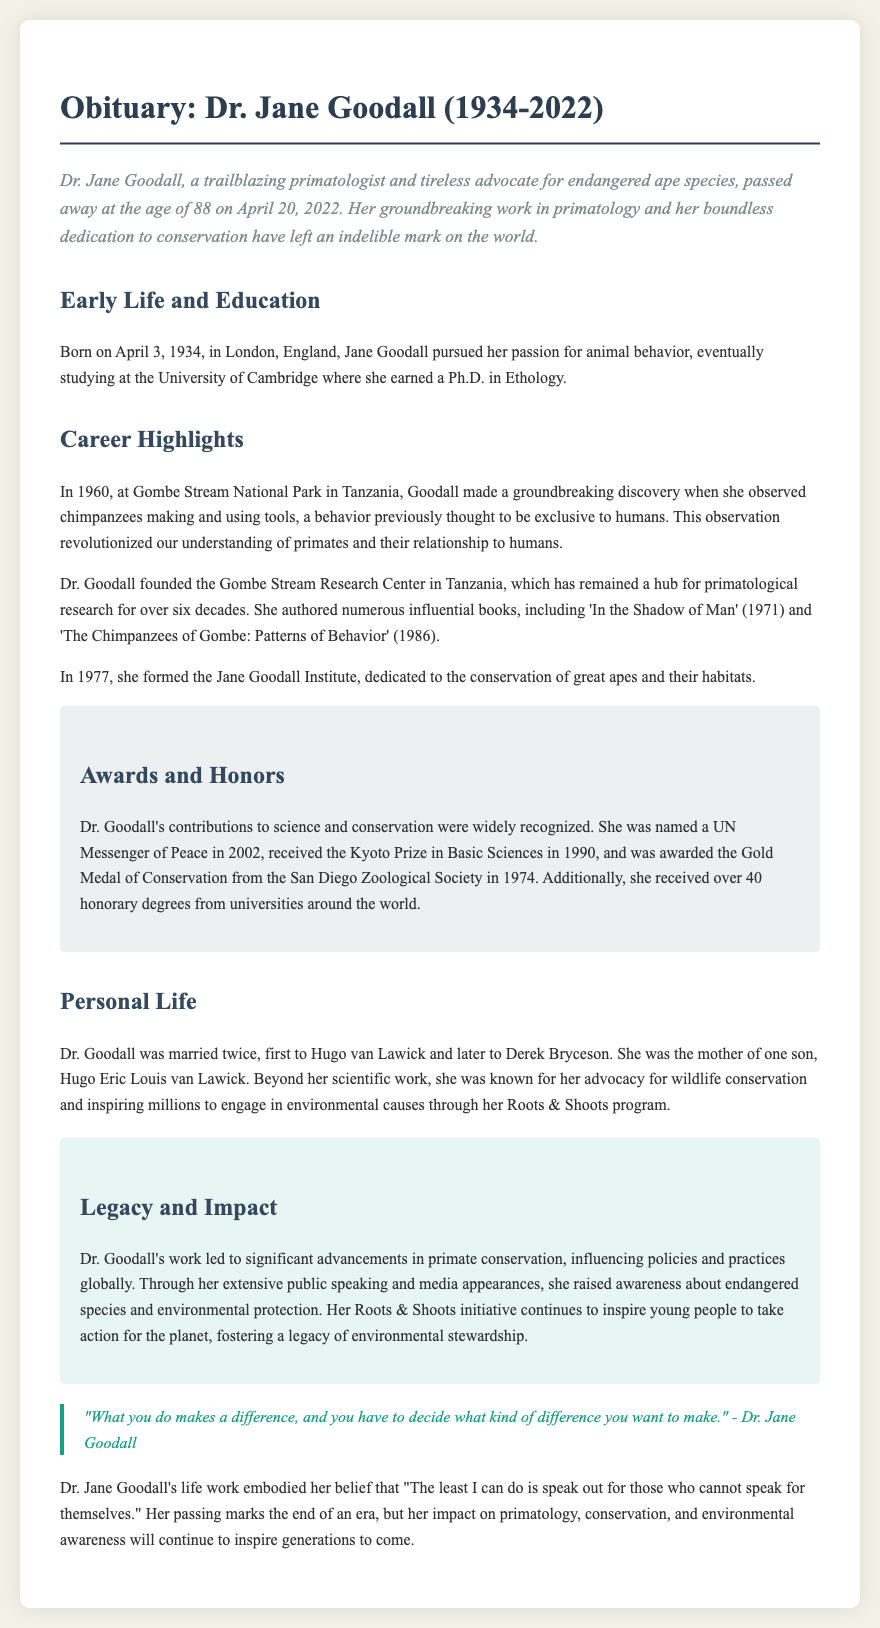what year was Dr. Jane Goodall born? The document states that she was born on April 3, 1934.
Answer: 1934 what groundbreaking discovery did Dr. Goodall make in 1960? In 1960, Dr. Goodall observed chimpanzees making and using tools.
Answer: making and using tools what institution did Dr. Goodall found in 1977? The document mentions that she formed the Jane Goodall Institute in 1977.
Answer: Jane Goodall Institute how many honorary degrees did Dr. Goodall receive? The obituary notes that she received over 40 honorary degrees from various universities.
Answer: over 40 what was the name of Dr. Goodall's first husband? The document indicates that her first husband was Hugo van Lawick.
Answer: Hugo van Lawick what initiative did Dr. Goodall create to inspire young people? The document refers to her Roots & Shoots program as the initiative she created.
Answer: Roots & Shoots what major award did Dr. Goodall receive in 1990? The document states that she received the Kyoto Prize in Basic Sciences in 1990.
Answer: Kyoto Prize in Basic Sciences what is the primary theme of Dr. Goodall's quote in the document? The quote emphasizes the importance of making a positive difference in the world.
Answer: importance of making a positive difference what does Dr. Goodall's legacy primarily focus on according to the document? The document highlights that her legacy focuses on primate conservation and environmental awareness.
Answer: primate conservation and environmental awareness 